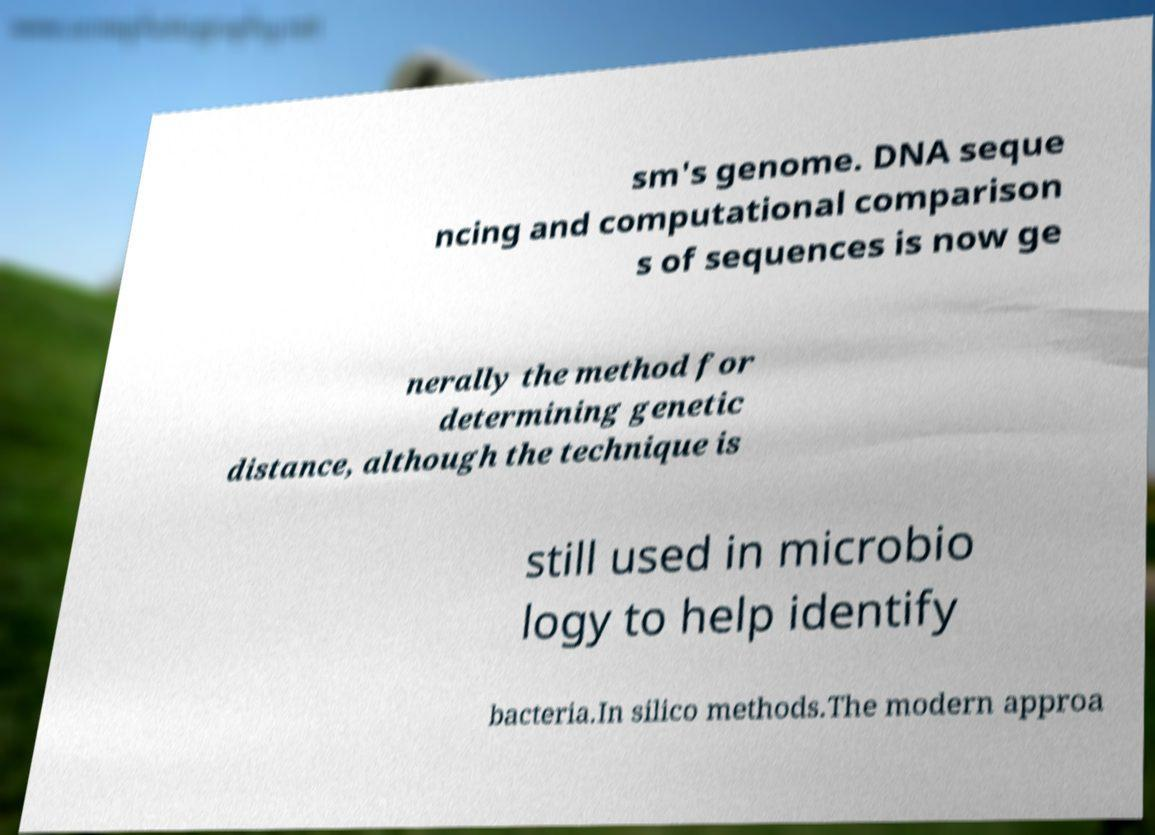Please read and relay the text visible in this image. What does it say? sm's genome. DNA seque ncing and computational comparison s of sequences is now ge nerally the method for determining genetic distance, although the technique is still used in microbio logy to help identify bacteria.In silico methods.The modern approa 